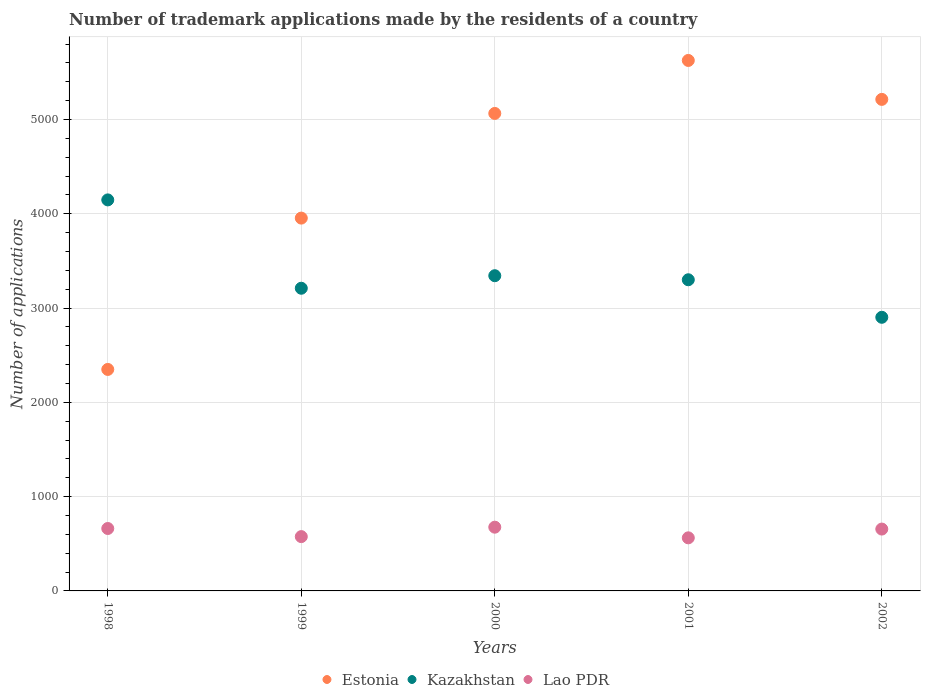How many different coloured dotlines are there?
Give a very brief answer. 3. Is the number of dotlines equal to the number of legend labels?
Provide a succinct answer. Yes. What is the number of trademark applications made by the residents in Kazakhstan in 1998?
Your answer should be compact. 4147. Across all years, what is the maximum number of trademark applications made by the residents in Kazakhstan?
Give a very brief answer. 4147. Across all years, what is the minimum number of trademark applications made by the residents in Lao PDR?
Make the answer very short. 563. In which year was the number of trademark applications made by the residents in Estonia minimum?
Offer a very short reply. 1998. What is the total number of trademark applications made by the residents in Lao PDR in the graph?
Provide a succinct answer. 3133. What is the difference between the number of trademark applications made by the residents in Kazakhstan in 1999 and that in 2002?
Give a very brief answer. 308. What is the difference between the number of trademark applications made by the residents in Kazakhstan in 1999 and the number of trademark applications made by the residents in Lao PDR in 2000?
Keep it short and to the point. 2534. What is the average number of trademark applications made by the residents in Estonia per year?
Make the answer very short. 4441.2. In the year 2002, what is the difference between the number of trademark applications made by the residents in Kazakhstan and number of trademark applications made by the residents in Lao PDR?
Offer a very short reply. 2246. What is the ratio of the number of trademark applications made by the residents in Kazakhstan in 1998 to that in 2002?
Ensure brevity in your answer.  1.43. Is the difference between the number of trademark applications made by the residents in Kazakhstan in 2000 and 2002 greater than the difference between the number of trademark applications made by the residents in Lao PDR in 2000 and 2002?
Ensure brevity in your answer.  Yes. What is the difference between the highest and the second highest number of trademark applications made by the residents in Kazakhstan?
Your answer should be very brief. 804. What is the difference between the highest and the lowest number of trademark applications made by the residents in Estonia?
Ensure brevity in your answer.  3277. In how many years, is the number of trademark applications made by the residents in Lao PDR greater than the average number of trademark applications made by the residents in Lao PDR taken over all years?
Offer a very short reply. 3. Is the sum of the number of trademark applications made by the residents in Kazakhstan in 1999 and 2000 greater than the maximum number of trademark applications made by the residents in Estonia across all years?
Your answer should be compact. Yes. Is it the case that in every year, the sum of the number of trademark applications made by the residents in Lao PDR and number of trademark applications made by the residents in Kazakhstan  is greater than the number of trademark applications made by the residents in Estonia?
Offer a very short reply. No. Does the number of trademark applications made by the residents in Kazakhstan monotonically increase over the years?
Keep it short and to the point. No. Is the number of trademark applications made by the residents in Lao PDR strictly greater than the number of trademark applications made by the residents in Estonia over the years?
Your answer should be very brief. No. Is the number of trademark applications made by the residents in Kazakhstan strictly less than the number of trademark applications made by the residents in Estonia over the years?
Make the answer very short. No. How many dotlines are there?
Provide a succinct answer. 3. Are the values on the major ticks of Y-axis written in scientific E-notation?
Keep it short and to the point. No. Does the graph contain any zero values?
Your answer should be very brief. No. Does the graph contain grids?
Offer a very short reply. Yes. Where does the legend appear in the graph?
Make the answer very short. Bottom center. How many legend labels are there?
Keep it short and to the point. 3. How are the legend labels stacked?
Provide a succinct answer. Horizontal. What is the title of the graph?
Your response must be concise. Number of trademark applications made by the residents of a country. Does "Bolivia" appear as one of the legend labels in the graph?
Your answer should be compact. No. What is the label or title of the X-axis?
Your answer should be compact. Years. What is the label or title of the Y-axis?
Your answer should be compact. Number of applications. What is the Number of applications of Estonia in 1998?
Offer a very short reply. 2349. What is the Number of applications of Kazakhstan in 1998?
Provide a succinct answer. 4147. What is the Number of applications in Lao PDR in 1998?
Provide a short and direct response. 662. What is the Number of applications in Estonia in 1999?
Your answer should be compact. 3954. What is the Number of applications of Kazakhstan in 1999?
Make the answer very short. 3210. What is the Number of applications of Lao PDR in 1999?
Make the answer very short. 576. What is the Number of applications in Estonia in 2000?
Provide a succinct answer. 5064. What is the Number of applications in Kazakhstan in 2000?
Your response must be concise. 3343. What is the Number of applications of Lao PDR in 2000?
Provide a short and direct response. 676. What is the Number of applications of Estonia in 2001?
Your answer should be compact. 5626. What is the Number of applications of Kazakhstan in 2001?
Your answer should be very brief. 3300. What is the Number of applications in Lao PDR in 2001?
Make the answer very short. 563. What is the Number of applications of Estonia in 2002?
Offer a terse response. 5213. What is the Number of applications in Kazakhstan in 2002?
Ensure brevity in your answer.  2902. What is the Number of applications in Lao PDR in 2002?
Give a very brief answer. 656. Across all years, what is the maximum Number of applications in Estonia?
Make the answer very short. 5626. Across all years, what is the maximum Number of applications in Kazakhstan?
Your answer should be very brief. 4147. Across all years, what is the maximum Number of applications in Lao PDR?
Give a very brief answer. 676. Across all years, what is the minimum Number of applications in Estonia?
Provide a short and direct response. 2349. Across all years, what is the minimum Number of applications of Kazakhstan?
Ensure brevity in your answer.  2902. Across all years, what is the minimum Number of applications of Lao PDR?
Your response must be concise. 563. What is the total Number of applications in Estonia in the graph?
Offer a terse response. 2.22e+04. What is the total Number of applications in Kazakhstan in the graph?
Make the answer very short. 1.69e+04. What is the total Number of applications in Lao PDR in the graph?
Provide a succinct answer. 3133. What is the difference between the Number of applications in Estonia in 1998 and that in 1999?
Your answer should be very brief. -1605. What is the difference between the Number of applications in Kazakhstan in 1998 and that in 1999?
Your response must be concise. 937. What is the difference between the Number of applications of Estonia in 1998 and that in 2000?
Keep it short and to the point. -2715. What is the difference between the Number of applications in Kazakhstan in 1998 and that in 2000?
Your answer should be very brief. 804. What is the difference between the Number of applications of Estonia in 1998 and that in 2001?
Provide a short and direct response. -3277. What is the difference between the Number of applications in Kazakhstan in 1998 and that in 2001?
Give a very brief answer. 847. What is the difference between the Number of applications in Lao PDR in 1998 and that in 2001?
Offer a terse response. 99. What is the difference between the Number of applications in Estonia in 1998 and that in 2002?
Your answer should be very brief. -2864. What is the difference between the Number of applications in Kazakhstan in 1998 and that in 2002?
Give a very brief answer. 1245. What is the difference between the Number of applications of Estonia in 1999 and that in 2000?
Offer a very short reply. -1110. What is the difference between the Number of applications of Kazakhstan in 1999 and that in 2000?
Give a very brief answer. -133. What is the difference between the Number of applications in Lao PDR in 1999 and that in 2000?
Make the answer very short. -100. What is the difference between the Number of applications in Estonia in 1999 and that in 2001?
Make the answer very short. -1672. What is the difference between the Number of applications in Kazakhstan in 1999 and that in 2001?
Give a very brief answer. -90. What is the difference between the Number of applications in Lao PDR in 1999 and that in 2001?
Provide a short and direct response. 13. What is the difference between the Number of applications in Estonia in 1999 and that in 2002?
Your response must be concise. -1259. What is the difference between the Number of applications in Kazakhstan in 1999 and that in 2002?
Offer a very short reply. 308. What is the difference between the Number of applications of Lao PDR in 1999 and that in 2002?
Provide a short and direct response. -80. What is the difference between the Number of applications of Estonia in 2000 and that in 2001?
Make the answer very short. -562. What is the difference between the Number of applications in Kazakhstan in 2000 and that in 2001?
Offer a very short reply. 43. What is the difference between the Number of applications of Lao PDR in 2000 and that in 2001?
Your response must be concise. 113. What is the difference between the Number of applications in Estonia in 2000 and that in 2002?
Give a very brief answer. -149. What is the difference between the Number of applications in Kazakhstan in 2000 and that in 2002?
Your answer should be compact. 441. What is the difference between the Number of applications in Estonia in 2001 and that in 2002?
Ensure brevity in your answer.  413. What is the difference between the Number of applications of Kazakhstan in 2001 and that in 2002?
Make the answer very short. 398. What is the difference between the Number of applications of Lao PDR in 2001 and that in 2002?
Offer a terse response. -93. What is the difference between the Number of applications of Estonia in 1998 and the Number of applications of Kazakhstan in 1999?
Your answer should be compact. -861. What is the difference between the Number of applications of Estonia in 1998 and the Number of applications of Lao PDR in 1999?
Provide a succinct answer. 1773. What is the difference between the Number of applications in Kazakhstan in 1998 and the Number of applications in Lao PDR in 1999?
Ensure brevity in your answer.  3571. What is the difference between the Number of applications of Estonia in 1998 and the Number of applications of Kazakhstan in 2000?
Offer a terse response. -994. What is the difference between the Number of applications of Estonia in 1998 and the Number of applications of Lao PDR in 2000?
Your answer should be very brief. 1673. What is the difference between the Number of applications of Kazakhstan in 1998 and the Number of applications of Lao PDR in 2000?
Keep it short and to the point. 3471. What is the difference between the Number of applications in Estonia in 1998 and the Number of applications in Kazakhstan in 2001?
Make the answer very short. -951. What is the difference between the Number of applications in Estonia in 1998 and the Number of applications in Lao PDR in 2001?
Give a very brief answer. 1786. What is the difference between the Number of applications in Kazakhstan in 1998 and the Number of applications in Lao PDR in 2001?
Offer a very short reply. 3584. What is the difference between the Number of applications in Estonia in 1998 and the Number of applications in Kazakhstan in 2002?
Your answer should be compact. -553. What is the difference between the Number of applications of Estonia in 1998 and the Number of applications of Lao PDR in 2002?
Offer a very short reply. 1693. What is the difference between the Number of applications of Kazakhstan in 1998 and the Number of applications of Lao PDR in 2002?
Offer a terse response. 3491. What is the difference between the Number of applications in Estonia in 1999 and the Number of applications in Kazakhstan in 2000?
Ensure brevity in your answer.  611. What is the difference between the Number of applications of Estonia in 1999 and the Number of applications of Lao PDR in 2000?
Offer a terse response. 3278. What is the difference between the Number of applications of Kazakhstan in 1999 and the Number of applications of Lao PDR in 2000?
Keep it short and to the point. 2534. What is the difference between the Number of applications of Estonia in 1999 and the Number of applications of Kazakhstan in 2001?
Your response must be concise. 654. What is the difference between the Number of applications in Estonia in 1999 and the Number of applications in Lao PDR in 2001?
Your response must be concise. 3391. What is the difference between the Number of applications in Kazakhstan in 1999 and the Number of applications in Lao PDR in 2001?
Your response must be concise. 2647. What is the difference between the Number of applications of Estonia in 1999 and the Number of applications of Kazakhstan in 2002?
Your answer should be compact. 1052. What is the difference between the Number of applications of Estonia in 1999 and the Number of applications of Lao PDR in 2002?
Give a very brief answer. 3298. What is the difference between the Number of applications in Kazakhstan in 1999 and the Number of applications in Lao PDR in 2002?
Provide a short and direct response. 2554. What is the difference between the Number of applications of Estonia in 2000 and the Number of applications of Kazakhstan in 2001?
Keep it short and to the point. 1764. What is the difference between the Number of applications in Estonia in 2000 and the Number of applications in Lao PDR in 2001?
Your response must be concise. 4501. What is the difference between the Number of applications in Kazakhstan in 2000 and the Number of applications in Lao PDR in 2001?
Make the answer very short. 2780. What is the difference between the Number of applications in Estonia in 2000 and the Number of applications in Kazakhstan in 2002?
Provide a short and direct response. 2162. What is the difference between the Number of applications of Estonia in 2000 and the Number of applications of Lao PDR in 2002?
Offer a very short reply. 4408. What is the difference between the Number of applications in Kazakhstan in 2000 and the Number of applications in Lao PDR in 2002?
Your answer should be compact. 2687. What is the difference between the Number of applications of Estonia in 2001 and the Number of applications of Kazakhstan in 2002?
Your response must be concise. 2724. What is the difference between the Number of applications of Estonia in 2001 and the Number of applications of Lao PDR in 2002?
Provide a succinct answer. 4970. What is the difference between the Number of applications in Kazakhstan in 2001 and the Number of applications in Lao PDR in 2002?
Your response must be concise. 2644. What is the average Number of applications in Estonia per year?
Make the answer very short. 4441.2. What is the average Number of applications in Kazakhstan per year?
Your answer should be compact. 3380.4. What is the average Number of applications in Lao PDR per year?
Your answer should be very brief. 626.6. In the year 1998, what is the difference between the Number of applications of Estonia and Number of applications of Kazakhstan?
Offer a very short reply. -1798. In the year 1998, what is the difference between the Number of applications in Estonia and Number of applications in Lao PDR?
Provide a succinct answer. 1687. In the year 1998, what is the difference between the Number of applications of Kazakhstan and Number of applications of Lao PDR?
Ensure brevity in your answer.  3485. In the year 1999, what is the difference between the Number of applications of Estonia and Number of applications of Kazakhstan?
Your answer should be very brief. 744. In the year 1999, what is the difference between the Number of applications of Estonia and Number of applications of Lao PDR?
Provide a short and direct response. 3378. In the year 1999, what is the difference between the Number of applications in Kazakhstan and Number of applications in Lao PDR?
Your response must be concise. 2634. In the year 2000, what is the difference between the Number of applications in Estonia and Number of applications in Kazakhstan?
Offer a very short reply. 1721. In the year 2000, what is the difference between the Number of applications of Estonia and Number of applications of Lao PDR?
Your response must be concise. 4388. In the year 2000, what is the difference between the Number of applications of Kazakhstan and Number of applications of Lao PDR?
Provide a succinct answer. 2667. In the year 2001, what is the difference between the Number of applications of Estonia and Number of applications of Kazakhstan?
Provide a short and direct response. 2326. In the year 2001, what is the difference between the Number of applications in Estonia and Number of applications in Lao PDR?
Provide a succinct answer. 5063. In the year 2001, what is the difference between the Number of applications of Kazakhstan and Number of applications of Lao PDR?
Provide a short and direct response. 2737. In the year 2002, what is the difference between the Number of applications in Estonia and Number of applications in Kazakhstan?
Your answer should be compact. 2311. In the year 2002, what is the difference between the Number of applications in Estonia and Number of applications in Lao PDR?
Keep it short and to the point. 4557. In the year 2002, what is the difference between the Number of applications of Kazakhstan and Number of applications of Lao PDR?
Your response must be concise. 2246. What is the ratio of the Number of applications in Estonia in 1998 to that in 1999?
Provide a succinct answer. 0.59. What is the ratio of the Number of applications in Kazakhstan in 1998 to that in 1999?
Keep it short and to the point. 1.29. What is the ratio of the Number of applications of Lao PDR in 1998 to that in 1999?
Your response must be concise. 1.15. What is the ratio of the Number of applications of Estonia in 1998 to that in 2000?
Ensure brevity in your answer.  0.46. What is the ratio of the Number of applications in Kazakhstan in 1998 to that in 2000?
Provide a short and direct response. 1.24. What is the ratio of the Number of applications of Lao PDR in 1998 to that in 2000?
Your answer should be compact. 0.98. What is the ratio of the Number of applications in Estonia in 1998 to that in 2001?
Offer a very short reply. 0.42. What is the ratio of the Number of applications in Kazakhstan in 1998 to that in 2001?
Provide a short and direct response. 1.26. What is the ratio of the Number of applications of Lao PDR in 1998 to that in 2001?
Make the answer very short. 1.18. What is the ratio of the Number of applications of Estonia in 1998 to that in 2002?
Offer a very short reply. 0.45. What is the ratio of the Number of applications of Kazakhstan in 1998 to that in 2002?
Give a very brief answer. 1.43. What is the ratio of the Number of applications of Lao PDR in 1998 to that in 2002?
Offer a terse response. 1.01. What is the ratio of the Number of applications in Estonia in 1999 to that in 2000?
Your answer should be very brief. 0.78. What is the ratio of the Number of applications of Kazakhstan in 1999 to that in 2000?
Give a very brief answer. 0.96. What is the ratio of the Number of applications of Lao PDR in 1999 to that in 2000?
Offer a very short reply. 0.85. What is the ratio of the Number of applications in Estonia in 1999 to that in 2001?
Make the answer very short. 0.7. What is the ratio of the Number of applications in Kazakhstan in 1999 to that in 2001?
Your response must be concise. 0.97. What is the ratio of the Number of applications in Lao PDR in 1999 to that in 2001?
Provide a succinct answer. 1.02. What is the ratio of the Number of applications of Estonia in 1999 to that in 2002?
Keep it short and to the point. 0.76. What is the ratio of the Number of applications of Kazakhstan in 1999 to that in 2002?
Your response must be concise. 1.11. What is the ratio of the Number of applications in Lao PDR in 1999 to that in 2002?
Your answer should be very brief. 0.88. What is the ratio of the Number of applications in Estonia in 2000 to that in 2001?
Provide a succinct answer. 0.9. What is the ratio of the Number of applications of Lao PDR in 2000 to that in 2001?
Your answer should be compact. 1.2. What is the ratio of the Number of applications of Estonia in 2000 to that in 2002?
Give a very brief answer. 0.97. What is the ratio of the Number of applications of Kazakhstan in 2000 to that in 2002?
Your answer should be very brief. 1.15. What is the ratio of the Number of applications in Lao PDR in 2000 to that in 2002?
Provide a succinct answer. 1.03. What is the ratio of the Number of applications in Estonia in 2001 to that in 2002?
Offer a very short reply. 1.08. What is the ratio of the Number of applications of Kazakhstan in 2001 to that in 2002?
Your answer should be compact. 1.14. What is the ratio of the Number of applications of Lao PDR in 2001 to that in 2002?
Give a very brief answer. 0.86. What is the difference between the highest and the second highest Number of applications in Estonia?
Offer a very short reply. 413. What is the difference between the highest and the second highest Number of applications of Kazakhstan?
Your answer should be compact. 804. What is the difference between the highest and the second highest Number of applications of Lao PDR?
Ensure brevity in your answer.  14. What is the difference between the highest and the lowest Number of applications in Estonia?
Keep it short and to the point. 3277. What is the difference between the highest and the lowest Number of applications of Kazakhstan?
Offer a terse response. 1245. What is the difference between the highest and the lowest Number of applications in Lao PDR?
Your answer should be very brief. 113. 